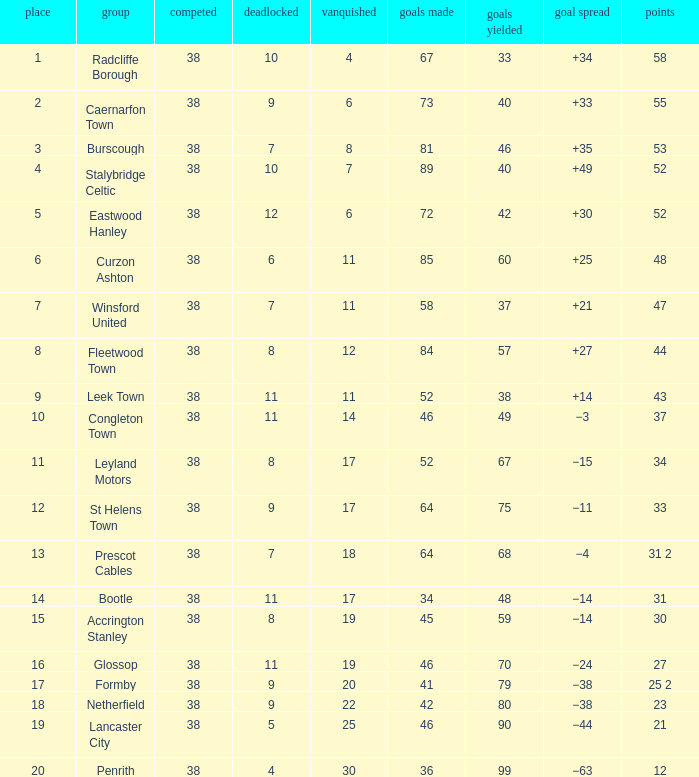WHAT IS THE SUM PLAYED WITH POINTS 1 OF 53, AND POSITION LARGER THAN 3? None. 